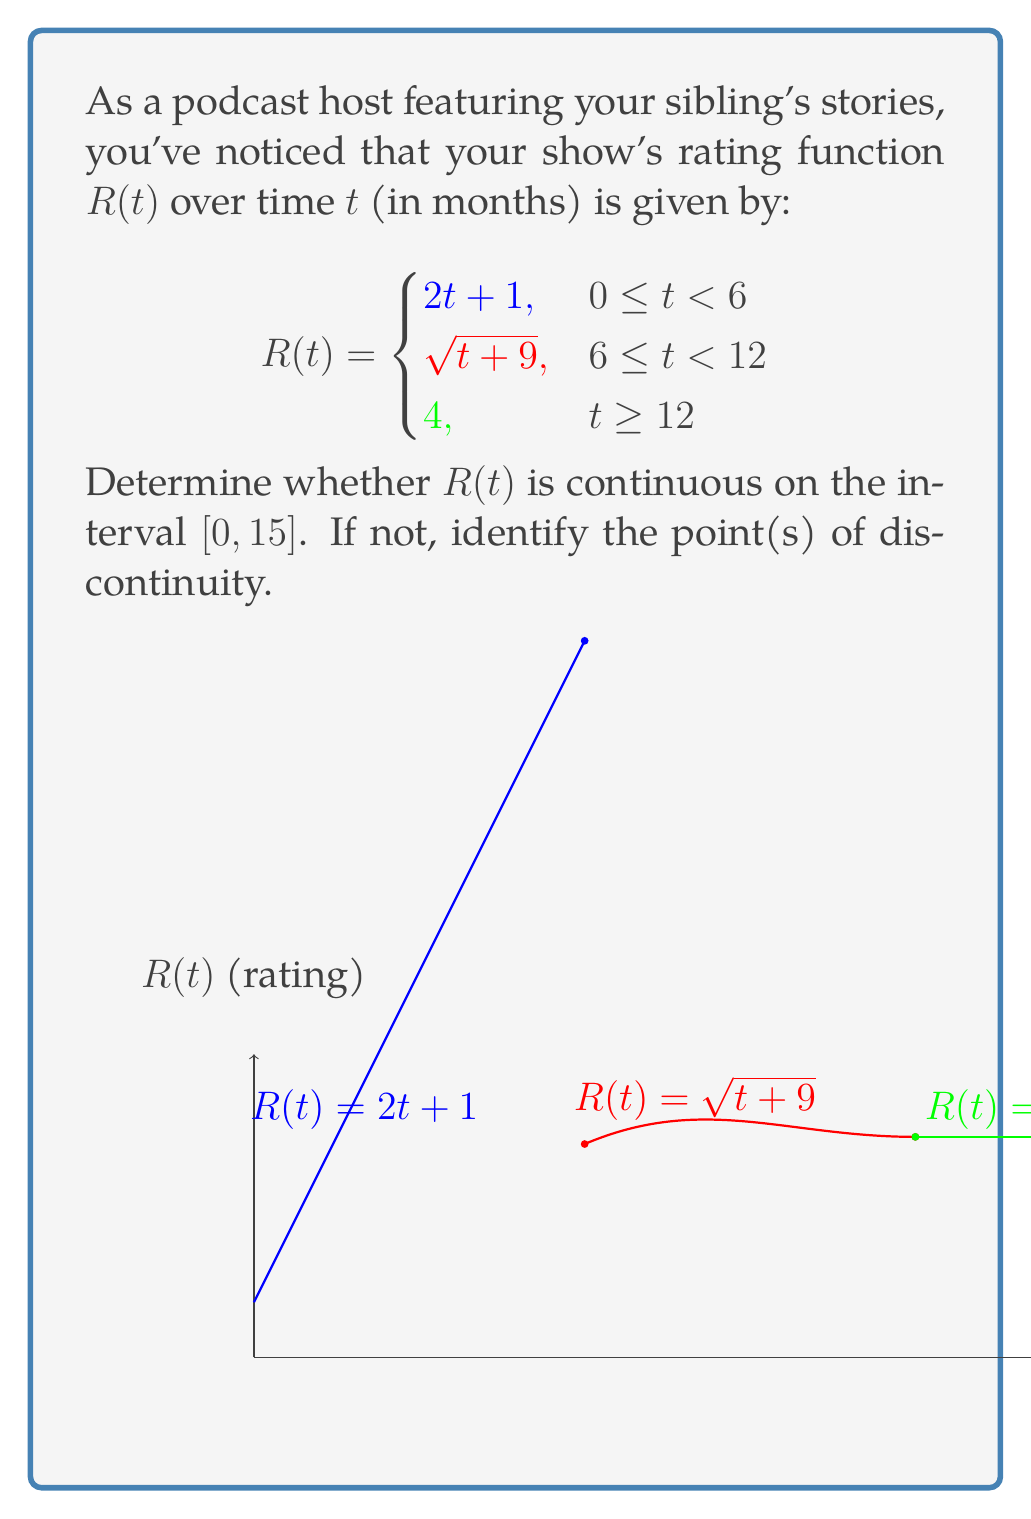Could you help me with this problem? To determine the continuity of $R(t)$ on $[0, 15]$, we need to check:
1. Continuity within each piece
2. Continuity at the transition points (t = 6 and t = 12)

Step 1: Continuity within each piece
- For $0 \leq t < 6$: $R(t) = 2t + 1$ is continuous (polynomial function)
- For $6 \leq t < 12$: $R(t) = \sqrt{t+9}$ is continuous (square root of a linear function)
- For $t \geq 12$: $R(t) = 4$ is continuous (constant function)

Step 2: Continuity at t = 6
Left limit: $\lim_{t \to 6^-} R(t) = \lim_{t \to 6^-} (2t + 1) = 13$
Right limit: $\lim_{t \to 6^+} R(t) = \lim_{t \to 6^+} \sqrt{t+9} = \sqrt{15} = \sqrt{15}$
$R(6) = \sqrt{6+9} = \sqrt{15}$

Since the left limit ≠ right limit = $R(6)$, there's a jump discontinuity at t = 6.

Step 3: Continuity at t = 12
Left limit: $\lim_{t \to 12^-} R(t) = \lim_{t \to 12^-} \sqrt{t+9} = \sqrt{21}$
Right limit: $\lim_{t \to 12^+} R(t) = 4$
$R(12) = 4$

Since the left limit ≠ right limit = $R(12)$, there's a jump discontinuity at t = 12.

Therefore, $R(t)$ is not continuous on $[0, 15]$ due to discontinuities at t = 6 and t = 12.
Answer: Not continuous; discontinuities at t = 6 and t = 12 